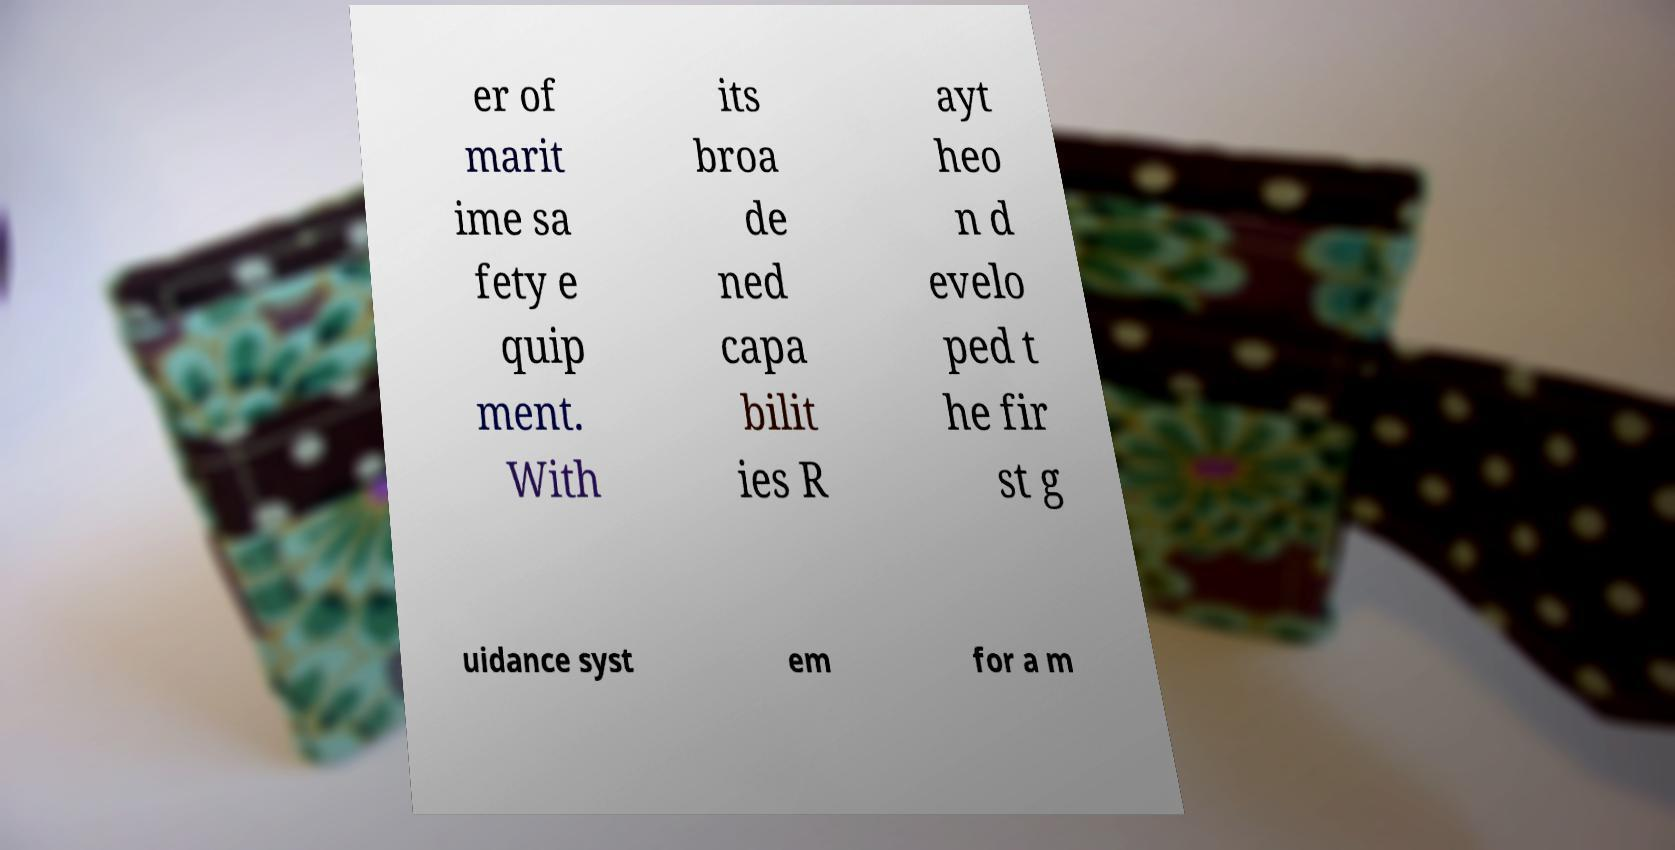What messages or text are displayed in this image? I need them in a readable, typed format. er of marit ime sa fety e quip ment. With its broa de ned capa bilit ies R ayt heo n d evelo ped t he fir st g uidance syst em for a m 